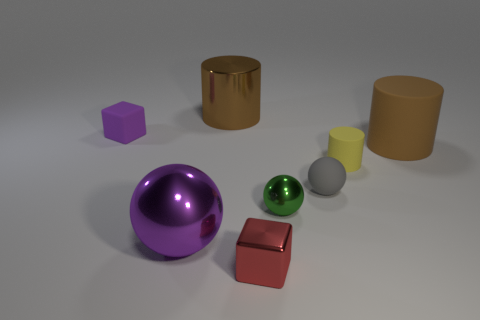Add 2 large brown cylinders. How many objects exist? 10 Subtract all blocks. How many objects are left? 6 Add 6 yellow rubber objects. How many yellow rubber objects are left? 7 Add 3 purple cubes. How many purple cubes exist? 4 Subtract 0 gray cubes. How many objects are left? 8 Subtract all large purple objects. Subtract all red objects. How many objects are left? 6 